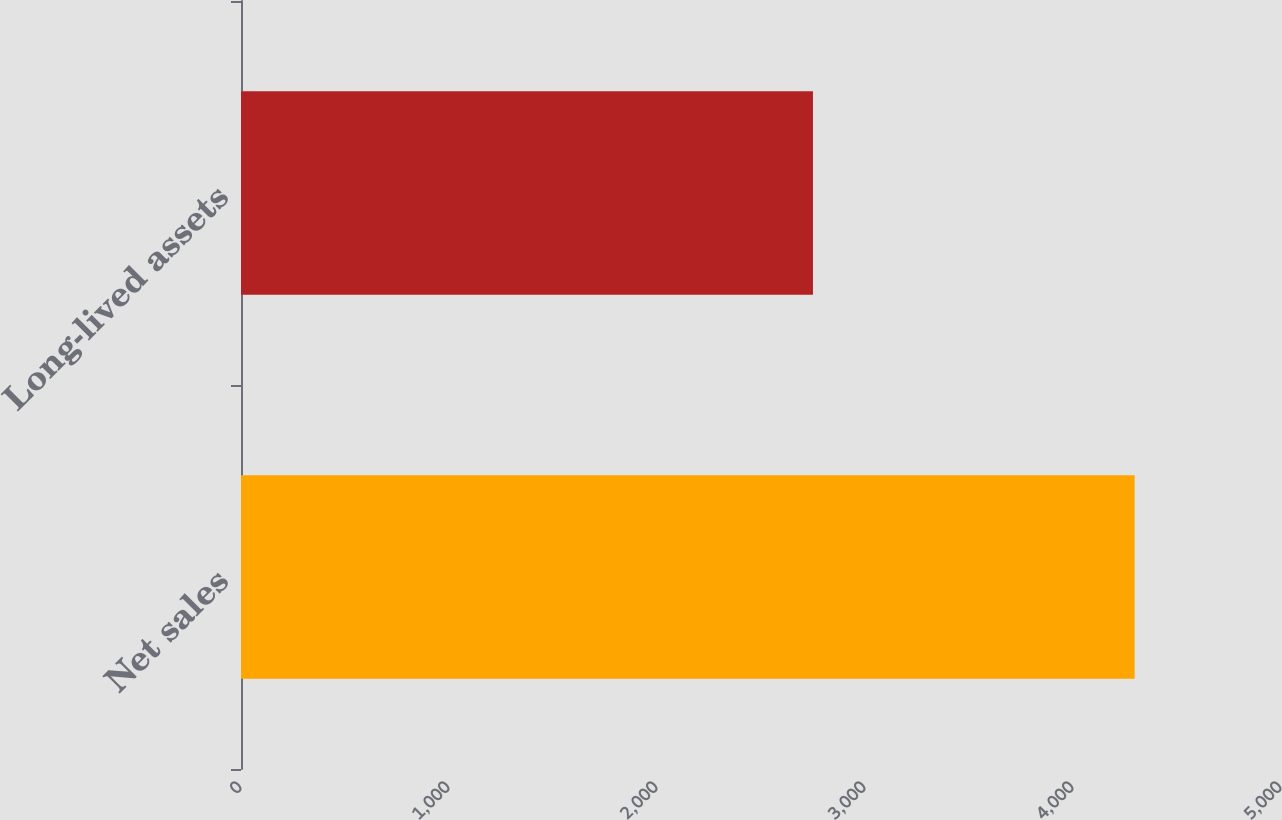Convert chart to OTSL. <chart><loc_0><loc_0><loc_500><loc_500><bar_chart><fcel>Net sales<fcel>Long-lived assets<nl><fcel>4296.3<fcel>2749.8<nl></chart> 